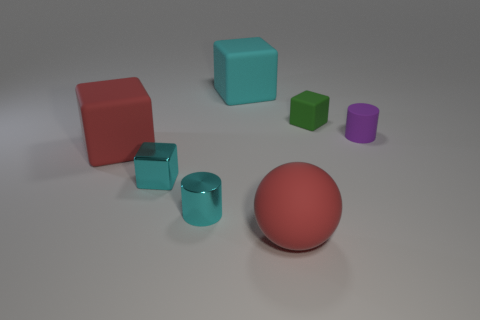Does the tiny metal cube have the same color as the tiny metallic cylinder?
Keep it short and to the point. Yes. Are there the same number of large cubes in front of the green matte block and small purple rubber cylinders?
Provide a succinct answer. Yes. What is the size of the cyan shiny cylinder?
Your answer should be compact. Small. There is a big object that is the same color as the tiny shiny cylinder; what material is it?
Offer a very short reply. Rubber. What number of big matte objects have the same color as the tiny metallic cylinder?
Your response must be concise. 1. Do the cyan shiny cylinder and the red rubber block have the same size?
Provide a short and direct response. No. There is a matte cube to the left of the cyan object behind the small purple rubber object; how big is it?
Offer a very short reply. Large. Do the small matte block and the big thing that is behind the purple cylinder have the same color?
Offer a very short reply. No. Is there a green block that has the same size as the purple matte thing?
Offer a terse response. Yes. How big is the red rubber object behind the tiny cyan metallic cylinder?
Your response must be concise. Large. 